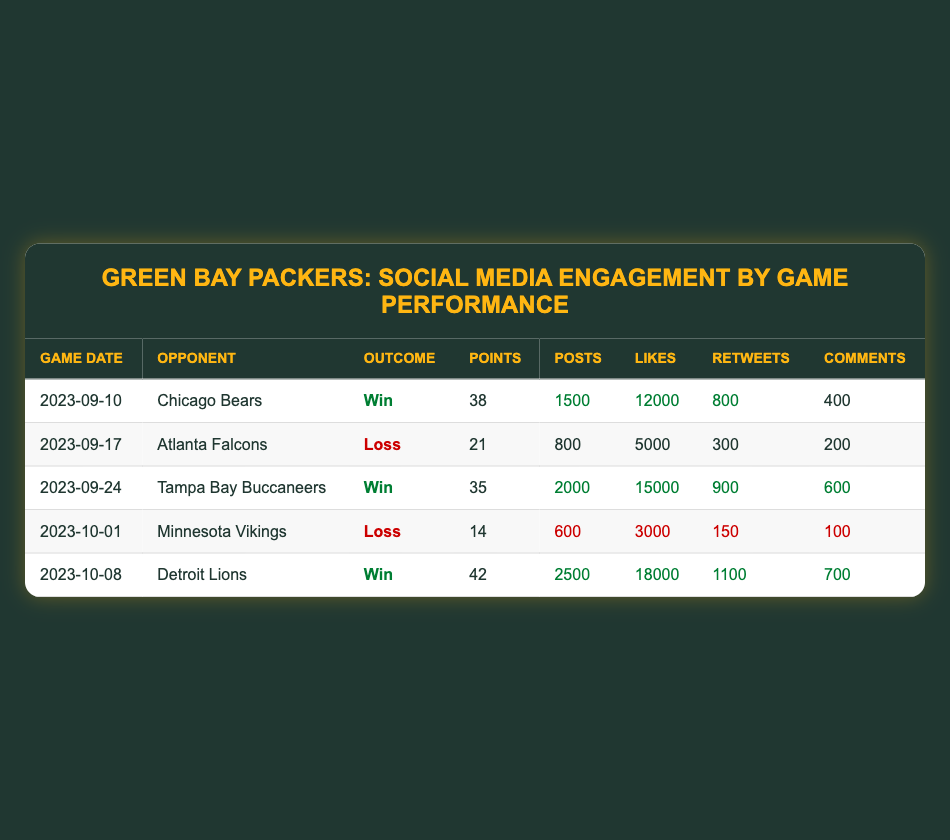What was the outcome of the game against the Chicago Bears? The table lists the opponent as "Chicago Bears" and the corresponding "Game Outcome" in that row is "Win".
Answer: Win How many points did the Green Bay Packers score against the Detroit Lions? In the row for the game against "Detroit Lions", the "Points Scored" column shows the value as 42.
Answer: 42 Which game resulted in the highest number of likes on social media? The game against "Detroit Lions" had the highest "Likes" with a total of 18000, which is greater than the likes from the other games.
Answer: Detroit Lions What is the total number of social media posts across all games where the Packers won? The total posts for the wins (Chicago Bears: 1500, Tampa Bay Buccaneers: 2000, Detroit Lions: 2500) sum to 1500 + 2000 + 2500 = 6000.
Answer: 6000 Did the Packers score more than 35 points in the game against the Atlanta Falcons? The "Points Scored" for the game against the "Atlanta Falcons" is 21, which is less than 35, therefore, this statement is false.
Answer: No What is the average number of comments received in games where the Packers lost? The games lost are against "Atlanta Falcons" (200 comments) and "Minnesota Vikings" (100 comments). Their average is (200 + 100) / 2 = 150.
Answer: 150 Which opponent had the second-lowest number of retweets, and how many did they receive? The game against "Minnesota Vikings" has 150 retweets, which is the lowest, followed by "Atlanta Falcons" with 300 retweets. So the second-lowest opponent is "Atlanta Falcons" with 300 retweets.
Answer: Atlanta Falcons, 300 How many total social media posts were made in all games where the Packers scored less than 30 points? The only game where they scored less than 30 points is against "Minnesota Vikings" (600 posts), so the total for those games is 600.
Answer: 600 What was the difference in likes between the game against Tampa Bay Buccaneers and the game against Atlanta Falcons? The likes for "Tampa Bay Buccaneers" are 15000 and for "Atlanta Falcons" are 5000. The difference is 15000 - 5000 = 10000.
Answer: 10000 